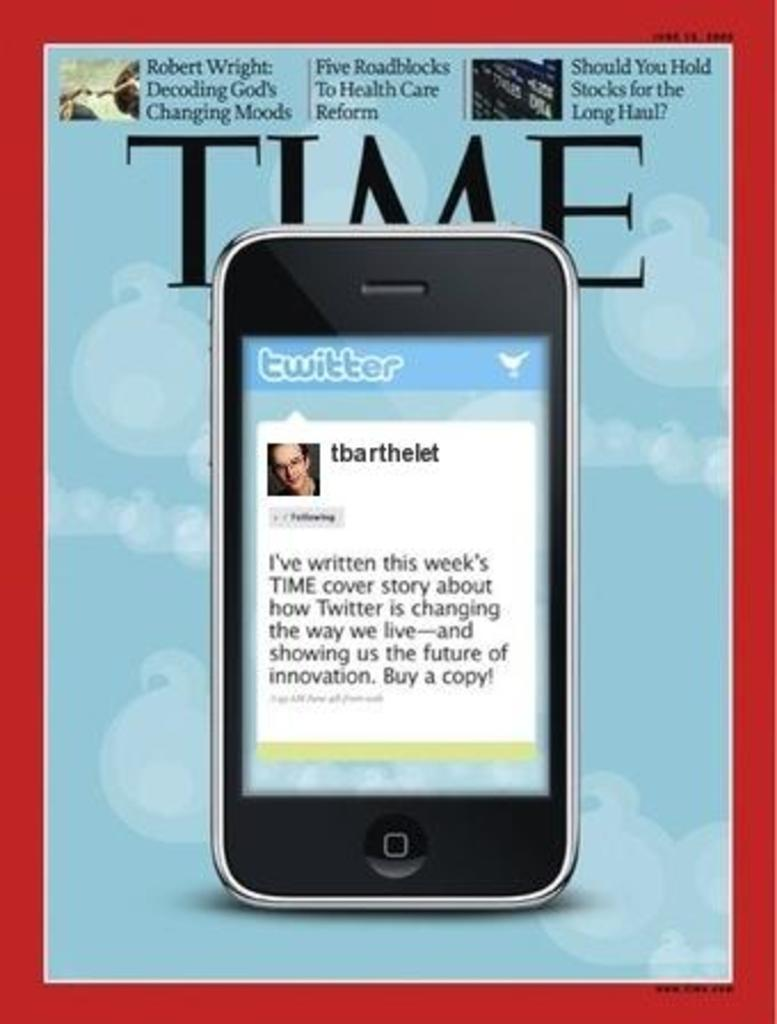<image>
Summarize the visual content of the image. A Time magazine displaying a cell phone on the front page 